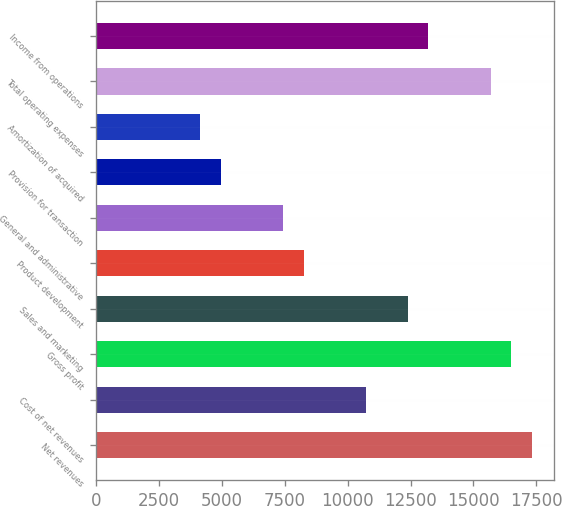Convert chart. <chart><loc_0><loc_0><loc_500><loc_500><bar_chart><fcel>Net revenues<fcel>Cost of net revenues<fcel>Gross profit<fcel>Sales and marketing<fcel>Product development<fcel>General and administrative<fcel>Provision for transaction<fcel>Amortization of acquired<fcel>Total operating expenses<fcel>Income from operations<nl><fcel>17339<fcel>10733.9<fcel>16513.4<fcel>12385.2<fcel>8257<fcel>7431.36<fcel>4954.44<fcel>4128.8<fcel>15687.8<fcel>13210.8<nl></chart> 